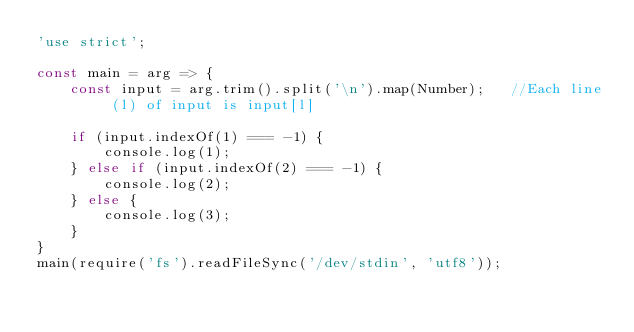Convert code to text. <code><loc_0><loc_0><loc_500><loc_500><_JavaScript_>'use strict';

const main = arg => {
    const input = arg.trim().split('\n').map(Number);		//Each line (l) of input is input[l]

    if (input.indexOf(1) === -1) {
        console.log(1);
    } else if (input.indexOf(2) === -1) {
        console.log(2);
    } else {
        console.log(3);
    }
}
main(require('fs').readFileSync('/dev/stdin', 'utf8'));</code> 